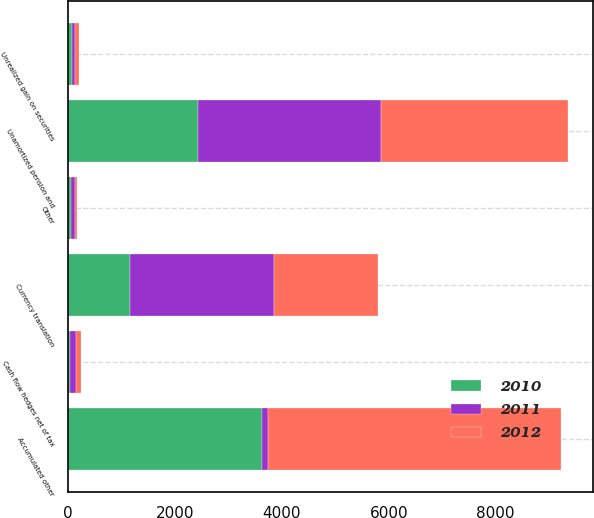<chart> <loc_0><loc_0><loc_500><loc_500><stacked_bar_chart><ecel><fcel>Currency translation<fcel>Cash flow hedges net of tax<fcel>Unamortized pension and<fcel>Unrealized gain on securities<fcel>Other<fcel>Accumulated other<nl><fcel>2012<fcel>1946<fcel>94<fcel>3491<fcel>80<fcel>36<fcel>5487<nl><fcel>2011<fcel>2688<fcel>112<fcel>3419<fcel>62<fcel>72<fcel>112<nl><fcel>2010<fcel>1159<fcel>38<fcel>2442<fcel>70<fcel>61<fcel>3630<nl></chart> 